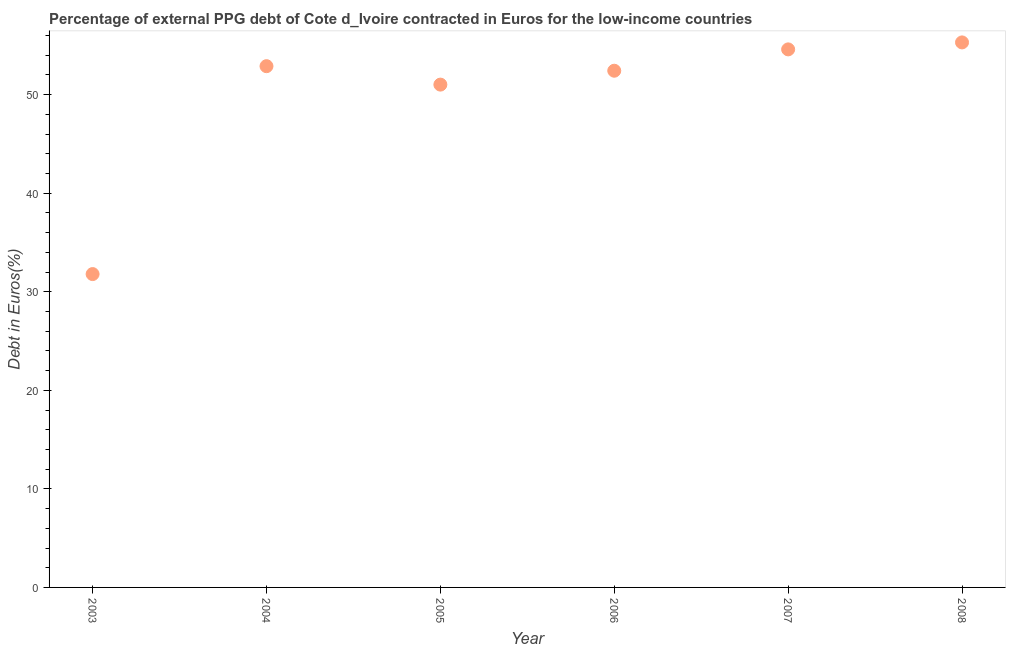What is the currency composition of ppg debt in 2003?
Your response must be concise. 31.79. Across all years, what is the maximum currency composition of ppg debt?
Give a very brief answer. 55.3. Across all years, what is the minimum currency composition of ppg debt?
Ensure brevity in your answer.  31.79. What is the sum of the currency composition of ppg debt?
Ensure brevity in your answer.  298.01. What is the difference between the currency composition of ppg debt in 2003 and 2006?
Keep it short and to the point. -20.63. What is the average currency composition of ppg debt per year?
Your answer should be very brief. 49.67. What is the median currency composition of ppg debt?
Your answer should be very brief. 52.66. Do a majority of the years between 2007 and 2004 (inclusive) have currency composition of ppg debt greater than 52 %?
Your answer should be compact. Yes. What is the ratio of the currency composition of ppg debt in 2004 to that in 2005?
Provide a short and direct response. 1.04. Is the currency composition of ppg debt in 2005 less than that in 2007?
Your response must be concise. Yes. What is the difference between the highest and the second highest currency composition of ppg debt?
Provide a succinct answer. 0.71. Is the sum of the currency composition of ppg debt in 2006 and 2007 greater than the maximum currency composition of ppg debt across all years?
Provide a succinct answer. Yes. What is the difference between the highest and the lowest currency composition of ppg debt?
Your answer should be compact. 23.51. Does the currency composition of ppg debt monotonically increase over the years?
Ensure brevity in your answer.  No. What is the difference between two consecutive major ticks on the Y-axis?
Offer a terse response. 10. Are the values on the major ticks of Y-axis written in scientific E-notation?
Offer a terse response. No. What is the title of the graph?
Make the answer very short. Percentage of external PPG debt of Cote d_Ivoire contracted in Euros for the low-income countries. What is the label or title of the X-axis?
Ensure brevity in your answer.  Year. What is the label or title of the Y-axis?
Ensure brevity in your answer.  Debt in Euros(%). What is the Debt in Euros(%) in 2003?
Your answer should be very brief. 31.79. What is the Debt in Euros(%) in 2004?
Keep it short and to the point. 52.89. What is the Debt in Euros(%) in 2005?
Offer a very short reply. 51.02. What is the Debt in Euros(%) in 2006?
Give a very brief answer. 52.42. What is the Debt in Euros(%) in 2007?
Your answer should be very brief. 54.59. What is the Debt in Euros(%) in 2008?
Make the answer very short. 55.3. What is the difference between the Debt in Euros(%) in 2003 and 2004?
Offer a terse response. -21.09. What is the difference between the Debt in Euros(%) in 2003 and 2005?
Offer a very short reply. -19.22. What is the difference between the Debt in Euros(%) in 2003 and 2006?
Provide a short and direct response. -20.63. What is the difference between the Debt in Euros(%) in 2003 and 2007?
Provide a succinct answer. -22.8. What is the difference between the Debt in Euros(%) in 2003 and 2008?
Offer a very short reply. -23.51. What is the difference between the Debt in Euros(%) in 2004 and 2005?
Your answer should be very brief. 1.87. What is the difference between the Debt in Euros(%) in 2004 and 2006?
Your answer should be very brief. 0.46. What is the difference between the Debt in Euros(%) in 2004 and 2007?
Offer a terse response. -1.7. What is the difference between the Debt in Euros(%) in 2004 and 2008?
Ensure brevity in your answer.  -2.41. What is the difference between the Debt in Euros(%) in 2005 and 2006?
Your response must be concise. -1.41. What is the difference between the Debt in Euros(%) in 2005 and 2007?
Offer a very short reply. -3.57. What is the difference between the Debt in Euros(%) in 2005 and 2008?
Your answer should be compact. -4.28. What is the difference between the Debt in Euros(%) in 2006 and 2007?
Your response must be concise. -2.17. What is the difference between the Debt in Euros(%) in 2006 and 2008?
Your answer should be compact. -2.87. What is the difference between the Debt in Euros(%) in 2007 and 2008?
Make the answer very short. -0.71. What is the ratio of the Debt in Euros(%) in 2003 to that in 2004?
Provide a succinct answer. 0.6. What is the ratio of the Debt in Euros(%) in 2003 to that in 2005?
Offer a terse response. 0.62. What is the ratio of the Debt in Euros(%) in 2003 to that in 2006?
Your answer should be very brief. 0.61. What is the ratio of the Debt in Euros(%) in 2003 to that in 2007?
Make the answer very short. 0.58. What is the ratio of the Debt in Euros(%) in 2003 to that in 2008?
Make the answer very short. 0.57. What is the ratio of the Debt in Euros(%) in 2004 to that in 2008?
Give a very brief answer. 0.96. What is the ratio of the Debt in Euros(%) in 2005 to that in 2007?
Provide a short and direct response. 0.94. What is the ratio of the Debt in Euros(%) in 2005 to that in 2008?
Keep it short and to the point. 0.92. What is the ratio of the Debt in Euros(%) in 2006 to that in 2008?
Provide a succinct answer. 0.95. 